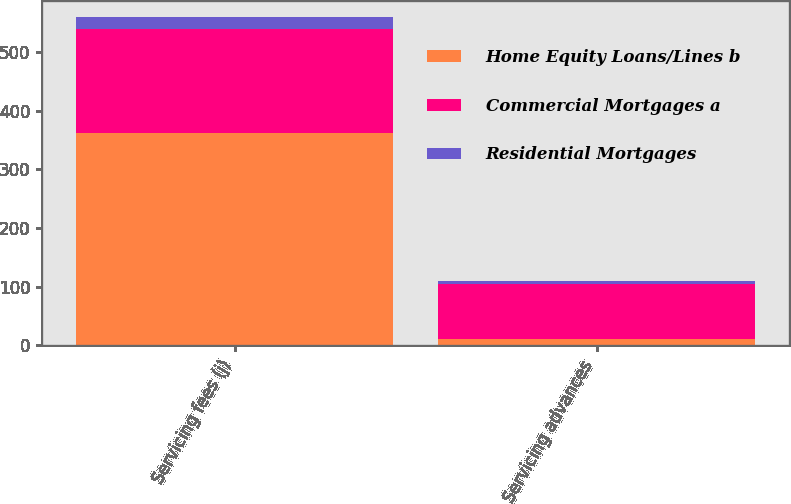Convert chart to OTSL. <chart><loc_0><loc_0><loc_500><loc_500><stacked_bar_chart><ecel><fcel>Servicing fees (j)<fcel>Servicing advances<nl><fcel>Home Equity Loans/Lines b<fcel>362<fcel>11<nl><fcel>Commercial Mortgages a<fcel>176<fcel>93<nl><fcel>Residential Mortgages<fcel>21<fcel>6<nl></chart> 